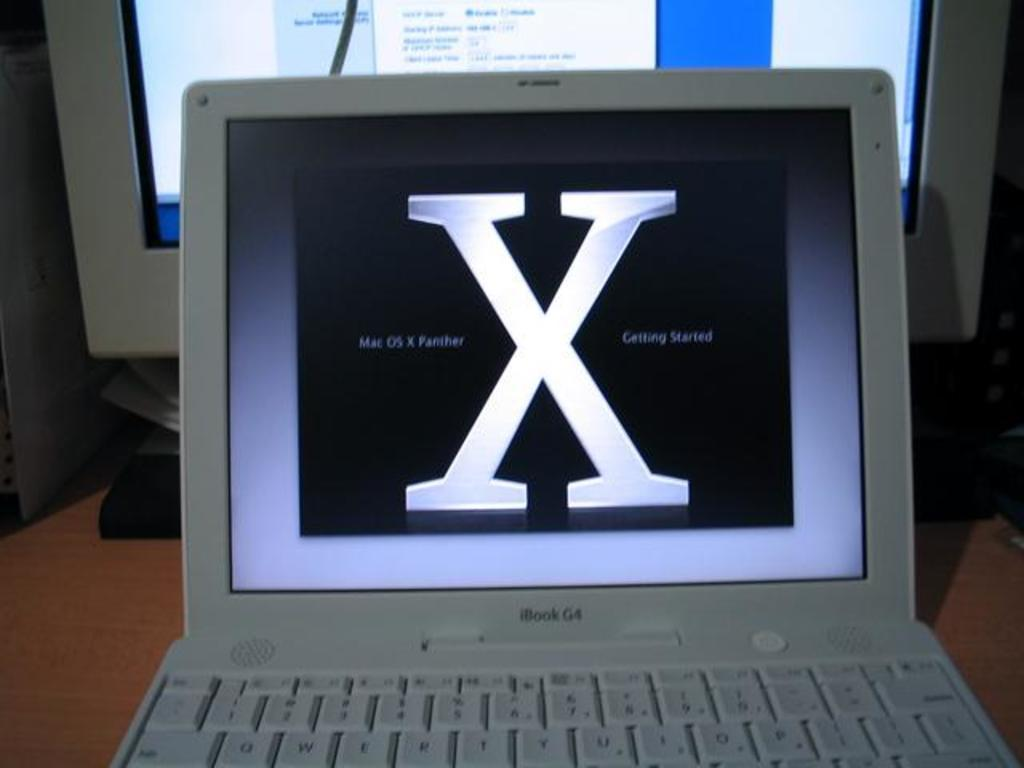<image>
Give a short and clear explanation of the subsequent image. An open iBook laptop sits in front of a PC. 